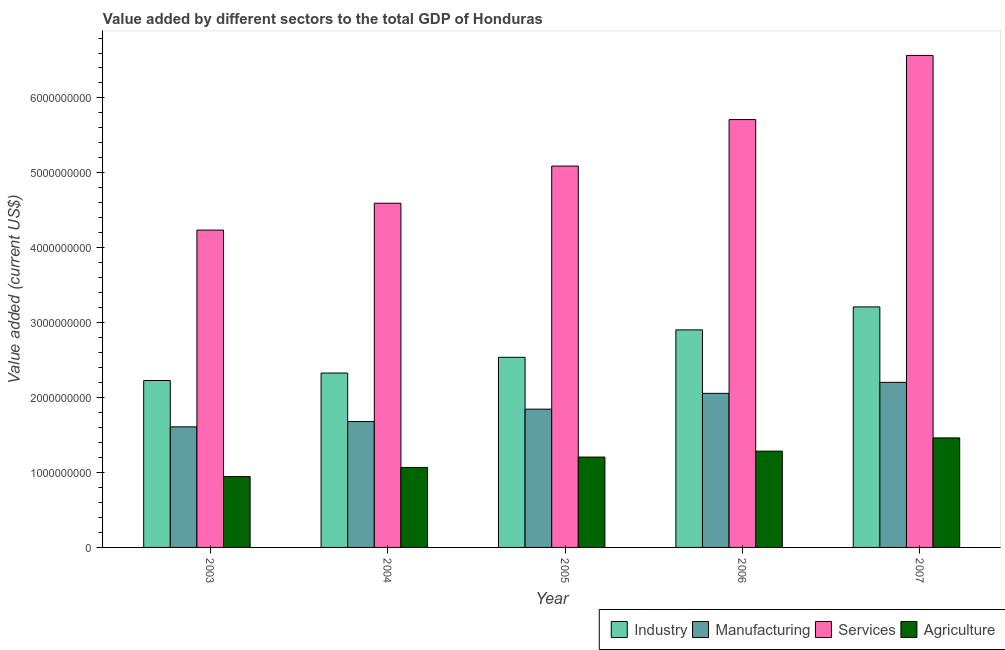How many different coloured bars are there?
Make the answer very short. 4. How many bars are there on the 5th tick from the left?
Provide a short and direct response. 4. What is the value added by agricultural sector in 2007?
Your answer should be very brief. 1.46e+09. Across all years, what is the maximum value added by manufacturing sector?
Provide a succinct answer. 2.20e+09. Across all years, what is the minimum value added by industrial sector?
Offer a terse response. 2.23e+09. In which year was the value added by industrial sector minimum?
Your response must be concise. 2003. What is the total value added by industrial sector in the graph?
Ensure brevity in your answer.  1.32e+1. What is the difference between the value added by manufacturing sector in 2005 and that in 2006?
Provide a succinct answer. -2.11e+08. What is the difference between the value added by manufacturing sector in 2007 and the value added by industrial sector in 2006?
Ensure brevity in your answer.  1.47e+08. What is the average value added by agricultural sector per year?
Make the answer very short. 1.19e+09. In how many years, is the value added by services sector greater than 4200000000 US$?
Your answer should be very brief. 5. What is the ratio of the value added by manufacturing sector in 2005 to that in 2006?
Ensure brevity in your answer.  0.9. What is the difference between the highest and the second highest value added by manufacturing sector?
Provide a succinct answer. 1.47e+08. What is the difference between the highest and the lowest value added by agricultural sector?
Ensure brevity in your answer.  5.17e+08. Is the sum of the value added by agricultural sector in 2005 and 2006 greater than the maximum value added by industrial sector across all years?
Give a very brief answer. Yes. Is it the case that in every year, the sum of the value added by services sector and value added by agricultural sector is greater than the sum of value added by manufacturing sector and value added by industrial sector?
Your answer should be very brief. Yes. What does the 2nd bar from the left in 2007 represents?
Offer a terse response. Manufacturing. What does the 3rd bar from the right in 2005 represents?
Make the answer very short. Manufacturing. Is it the case that in every year, the sum of the value added by industrial sector and value added by manufacturing sector is greater than the value added by services sector?
Ensure brevity in your answer.  No. How many bars are there?
Your answer should be compact. 20. Are all the bars in the graph horizontal?
Give a very brief answer. No. How many years are there in the graph?
Ensure brevity in your answer.  5. Does the graph contain any zero values?
Your response must be concise. No. How many legend labels are there?
Your response must be concise. 4. How are the legend labels stacked?
Ensure brevity in your answer.  Horizontal. What is the title of the graph?
Give a very brief answer. Value added by different sectors to the total GDP of Honduras. Does "Luxembourg" appear as one of the legend labels in the graph?
Your response must be concise. No. What is the label or title of the Y-axis?
Your answer should be very brief. Value added (current US$). What is the Value added (current US$) of Industry in 2003?
Your answer should be compact. 2.23e+09. What is the Value added (current US$) of Manufacturing in 2003?
Provide a short and direct response. 1.61e+09. What is the Value added (current US$) in Services in 2003?
Your answer should be very brief. 4.24e+09. What is the Value added (current US$) in Agriculture in 2003?
Keep it short and to the point. 9.45e+08. What is the Value added (current US$) in Industry in 2004?
Offer a terse response. 2.33e+09. What is the Value added (current US$) in Manufacturing in 2004?
Offer a very short reply. 1.68e+09. What is the Value added (current US$) of Services in 2004?
Ensure brevity in your answer.  4.59e+09. What is the Value added (current US$) of Agriculture in 2004?
Give a very brief answer. 1.07e+09. What is the Value added (current US$) of Industry in 2005?
Offer a very short reply. 2.54e+09. What is the Value added (current US$) of Manufacturing in 2005?
Your answer should be compact. 1.85e+09. What is the Value added (current US$) of Services in 2005?
Ensure brevity in your answer.  5.09e+09. What is the Value added (current US$) of Agriculture in 2005?
Offer a very short reply. 1.21e+09. What is the Value added (current US$) of Industry in 2006?
Ensure brevity in your answer.  2.90e+09. What is the Value added (current US$) of Manufacturing in 2006?
Offer a terse response. 2.06e+09. What is the Value added (current US$) in Services in 2006?
Your response must be concise. 5.71e+09. What is the Value added (current US$) in Agriculture in 2006?
Provide a short and direct response. 1.29e+09. What is the Value added (current US$) of Industry in 2007?
Give a very brief answer. 3.21e+09. What is the Value added (current US$) in Manufacturing in 2007?
Offer a terse response. 2.20e+09. What is the Value added (current US$) of Services in 2007?
Give a very brief answer. 6.57e+09. What is the Value added (current US$) of Agriculture in 2007?
Your answer should be very brief. 1.46e+09. Across all years, what is the maximum Value added (current US$) of Industry?
Your answer should be compact. 3.21e+09. Across all years, what is the maximum Value added (current US$) of Manufacturing?
Provide a short and direct response. 2.20e+09. Across all years, what is the maximum Value added (current US$) in Services?
Offer a very short reply. 6.57e+09. Across all years, what is the maximum Value added (current US$) in Agriculture?
Give a very brief answer. 1.46e+09. Across all years, what is the minimum Value added (current US$) in Industry?
Provide a succinct answer. 2.23e+09. Across all years, what is the minimum Value added (current US$) of Manufacturing?
Ensure brevity in your answer.  1.61e+09. Across all years, what is the minimum Value added (current US$) in Services?
Make the answer very short. 4.24e+09. Across all years, what is the minimum Value added (current US$) in Agriculture?
Ensure brevity in your answer.  9.45e+08. What is the total Value added (current US$) of Industry in the graph?
Your response must be concise. 1.32e+1. What is the total Value added (current US$) of Manufacturing in the graph?
Your answer should be compact. 9.40e+09. What is the total Value added (current US$) in Services in the graph?
Keep it short and to the point. 2.62e+1. What is the total Value added (current US$) of Agriculture in the graph?
Your answer should be compact. 5.97e+09. What is the difference between the Value added (current US$) of Industry in 2003 and that in 2004?
Your answer should be compact. -9.98e+07. What is the difference between the Value added (current US$) in Manufacturing in 2003 and that in 2004?
Ensure brevity in your answer.  -7.09e+07. What is the difference between the Value added (current US$) in Services in 2003 and that in 2004?
Provide a short and direct response. -3.59e+08. What is the difference between the Value added (current US$) in Agriculture in 2003 and that in 2004?
Provide a succinct answer. -1.22e+08. What is the difference between the Value added (current US$) in Industry in 2003 and that in 2005?
Offer a terse response. -3.10e+08. What is the difference between the Value added (current US$) in Manufacturing in 2003 and that in 2005?
Make the answer very short. -2.36e+08. What is the difference between the Value added (current US$) in Services in 2003 and that in 2005?
Keep it short and to the point. -8.55e+08. What is the difference between the Value added (current US$) of Agriculture in 2003 and that in 2005?
Make the answer very short. -2.61e+08. What is the difference between the Value added (current US$) of Industry in 2003 and that in 2006?
Provide a succinct answer. -6.76e+08. What is the difference between the Value added (current US$) in Manufacturing in 2003 and that in 2006?
Give a very brief answer. -4.47e+08. What is the difference between the Value added (current US$) in Services in 2003 and that in 2006?
Keep it short and to the point. -1.48e+09. What is the difference between the Value added (current US$) of Agriculture in 2003 and that in 2006?
Keep it short and to the point. -3.40e+08. What is the difference between the Value added (current US$) in Industry in 2003 and that in 2007?
Your answer should be compact. -9.83e+08. What is the difference between the Value added (current US$) in Manufacturing in 2003 and that in 2007?
Keep it short and to the point. -5.94e+08. What is the difference between the Value added (current US$) in Services in 2003 and that in 2007?
Your answer should be very brief. -2.33e+09. What is the difference between the Value added (current US$) in Agriculture in 2003 and that in 2007?
Offer a terse response. -5.17e+08. What is the difference between the Value added (current US$) in Industry in 2004 and that in 2005?
Provide a short and direct response. -2.10e+08. What is the difference between the Value added (current US$) of Manufacturing in 2004 and that in 2005?
Keep it short and to the point. -1.65e+08. What is the difference between the Value added (current US$) in Services in 2004 and that in 2005?
Ensure brevity in your answer.  -4.96e+08. What is the difference between the Value added (current US$) in Agriculture in 2004 and that in 2005?
Ensure brevity in your answer.  -1.39e+08. What is the difference between the Value added (current US$) in Industry in 2004 and that in 2006?
Make the answer very short. -5.76e+08. What is the difference between the Value added (current US$) in Manufacturing in 2004 and that in 2006?
Give a very brief answer. -3.76e+08. What is the difference between the Value added (current US$) of Services in 2004 and that in 2006?
Your response must be concise. -1.12e+09. What is the difference between the Value added (current US$) of Agriculture in 2004 and that in 2006?
Offer a terse response. -2.18e+08. What is the difference between the Value added (current US$) in Industry in 2004 and that in 2007?
Offer a terse response. -8.83e+08. What is the difference between the Value added (current US$) in Manufacturing in 2004 and that in 2007?
Your answer should be very brief. -5.23e+08. What is the difference between the Value added (current US$) in Services in 2004 and that in 2007?
Your answer should be compact. -1.97e+09. What is the difference between the Value added (current US$) in Agriculture in 2004 and that in 2007?
Offer a terse response. -3.95e+08. What is the difference between the Value added (current US$) in Industry in 2005 and that in 2006?
Make the answer very short. -3.66e+08. What is the difference between the Value added (current US$) of Manufacturing in 2005 and that in 2006?
Your answer should be compact. -2.11e+08. What is the difference between the Value added (current US$) of Services in 2005 and that in 2006?
Your answer should be compact. -6.21e+08. What is the difference between the Value added (current US$) of Agriculture in 2005 and that in 2006?
Offer a very short reply. -7.93e+07. What is the difference between the Value added (current US$) of Industry in 2005 and that in 2007?
Provide a succinct answer. -6.73e+08. What is the difference between the Value added (current US$) of Manufacturing in 2005 and that in 2007?
Your answer should be very brief. -3.58e+08. What is the difference between the Value added (current US$) of Services in 2005 and that in 2007?
Make the answer very short. -1.48e+09. What is the difference between the Value added (current US$) of Agriculture in 2005 and that in 2007?
Make the answer very short. -2.56e+08. What is the difference between the Value added (current US$) of Industry in 2006 and that in 2007?
Offer a terse response. -3.07e+08. What is the difference between the Value added (current US$) in Manufacturing in 2006 and that in 2007?
Give a very brief answer. -1.47e+08. What is the difference between the Value added (current US$) of Services in 2006 and that in 2007?
Provide a short and direct response. -8.56e+08. What is the difference between the Value added (current US$) of Agriculture in 2006 and that in 2007?
Make the answer very short. -1.77e+08. What is the difference between the Value added (current US$) of Industry in 2003 and the Value added (current US$) of Manufacturing in 2004?
Offer a terse response. 5.48e+08. What is the difference between the Value added (current US$) of Industry in 2003 and the Value added (current US$) of Services in 2004?
Make the answer very short. -2.37e+09. What is the difference between the Value added (current US$) of Industry in 2003 and the Value added (current US$) of Agriculture in 2004?
Make the answer very short. 1.16e+09. What is the difference between the Value added (current US$) of Manufacturing in 2003 and the Value added (current US$) of Services in 2004?
Offer a very short reply. -2.98e+09. What is the difference between the Value added (current US$) of Manufacturing in 2003 and the Value added (current US$) of Agriculture in 2004?
Offer a very short reply. 5.42e+08. What is the difference between the Value added (current US$) in Services in 2003 and the Value added (current US$) in Agriculture in 2004?
Your answer should be compact. 3.17e+09. What is the difference between the Value added (current US$) in Industry in 2003 and the Value added (current US$) in Manufacturing in 2005?
Make the answer very short. 3.82e+08. What is the difference between the Value added (current US$) of Industry in 2003 and the Value added (current US$) of Services in 2005?
Ensure brevity in your answer.  -2.86e+09. What is the difference between the Value added (current US$) of Industry in 2003 and the Value added (current US$) of Agriculture in 2005?
Provide a short and direct response. 1.02e+09. What is the difference between the Value added (current US$) of Manufacturing in 2003 and the Value added (current US$) of Services in 2005?
Make the answer very short. -3.48e+09. What is the difference between the Value added (current US$) of Manufacturing in 2003 and the Value added (current US$) of Agriculture in 2005?
Offer a very short reply. 4.03e+08. What is the difference between the Value added (current US$) of Services in 2003 and the Value added (current US$) of Agriculture in 2005?
Provide a short and direct response. 3.03e+09. What is the difference between the Value added (current US$) in Industry in 2003 and the Value added (current US$) in Manufacturing in 2006?
Provide a succinct answer. 1.71e+08. What is the difference between the Value added (current US$) of Industry in 2003 and the Value added (current US$) of Services in 2006?
Your response must be concise. -3.48e+09. What is the difference between the Value added (current US$) of Industry in 2003 and the Value added (current US$) of Agriculture in 2006?
Ensure brevity in your answer.  9.43e+08. What is the difference between the Value added (current US$) in Manufacturing in 2003 and the Value added (current US$) in Services in 2006?
Provide a short and direct response. -4.10e+09. What is the difference between the Value added (current US$) in Manufacturing in 2003 and the Value added (current US$) in Agriculture in 2006?
Offer a terse response. 3.24e+08. What is the difference between the Value added (current US$) of Services in 2003 and the Value added (current US$) of Agriculture in 2006?
Offer a terse response. 2.95e+09. What is the difference between the Value added (current US$) in Industry in 2003 and the Value added (current US$) in Manufacturing in 2007?
Make the answer very short. 2.45e+07. What is the difference between the Value added (current US$) of Industry in 2003 and the Value added (current US$) of Services in 2007?
Give a very brief answer. -4.34e+09. What is the difference between the Value added (current US$) in Industry in 2003 and the Value added (current US$) in Agriculture in 2007?
Give a very brief answer. 7.66e+08. What is the difference between the Value added (current US$) of Manufacturing in 2003 and the Value added (current US$) of Services in 2007?
Provide a succinct answer. -4.96e+09. What is the difference between the Value added (current US$) of Manufacturing in 2003 and the Value added (current US$) of Agriculture in 2007?
Your answer should be compact. 1.48e+08. What is the difference between the Value added (current US$) of Services in 2003 and the Value added (current US$) of Agriculture in 2007?
Give a very brief answer. 2.77e+09. What is the difference between the Value added (current US$) of Industry in 2004 and the Value added (current US$) of Manufacturing in 2005?
Your response must be concise. 4.82e+08. What is the difference between the Value added (current US$) in Industry in 2004 and the Value added (current US$) in Services in 2005?
Provide a short and direct response. -2.76e+09. What is the difference between the Value added (current US$) of Industry in 2004 and the Value added (current US$) of Agriculture in 2005?
Provide a short and direct response. 1.12e+09. What is the difference between the Value added (current US$) in Manufacturing in 2004 and the Value added (current US$) in Services in 2005?
Make the answer very short. -3.41e+09. What is the difference between the Value added (current US$) in Manufacturing in 2004 and the Value added (current US$) in Agriculture in 2005?
Offer a very short reply. 4.74e+08. What is the difference between the Value added (current US$) of Services in 2004 and the Value added (current US$) of Agriculture in 2005?
Keep it short and to the point. 3.39e+09. What is the difference between the Value added (current US$) of Industry in 2004 and the Value added (current US$) of Manufacturing in 2006?
Offer a terse response. 2.71e+08. What is the difference between the Value added (current US$) of Industry in 2004 and the Value added (current US$) of Services in 2006?
Provide a short and direct response. -3.38e+09. What is the difference between the Value added (current US$) of Industry in 2004 and the Value added (current US$) of Agriculture in 2006?
Keep it short and to the point. 1.04e+09. What is the difference between the Value added (current US$) in Manufacturing in 2004 and the Value added (current US$) in Services in 2006?
Provide a succinct answer. -4.03e+09. What is the difference between the Value added (current US$) of Manufacturing in 2004 and the Value added (current US$) of Agriculture in 2006?
Your answer should be very brief. 3.95e+08. What is the difference between the Value added (current US$) of Services in 2004 and the Value added (current US$) of Agriculture in 2006?
Provide a short and direct response. 3.31e+09. What is the difference between the Value added (current US$) in Industry in 2004 and the Value added (current US$) in Manufacturing in 2007?
Offer a terse response. 1.24e+08. What is the difference between the Value added (current US$) of Industry in 2004 and the Value added (current US$) of Services in 2007?
Offer a terse response. -4.24e+09. What is the difference between the Value added (current US$) in Industry in 2004 and the Value added (current US$) in Agriculture in 2007?
Offer a terse response. 8.66e+08. What is the difference between the Value added (current US$) of Manufacturing in 2004 and the Value added (current US$) of Services in 2007?
Your answer should be very brief. -4.89e+09. What is the difference between the Value added (current US$) of Manufacturing in 2004 and the Value added (current US$) of Agriculture in 2007?
Make the answer very short. 2.18e+08. What is the difference between the Value added (current US$) of Services in 2004 and the Value added (current US$) of Agriculture in 2007?
Your answer should be compact. 3.13e+09. What is the difference between the Value added (current US$) in Industry in 2005 and the Value added (current US$) in Manufacturing in 2006?
Offer a very short reply. 4.81e+08. What is the difference between the Value added (current US$) of Industry in 2005 and the Value added (current US$) of Services in 2006?
Provide a short and direct response. -3.17e+09. What is the difference between the Value added (current US$) of Industry in 2005 and the Value added (current US$) of Agriculture in 2006?
Provide a short and direct response. 1.25e+09. What is the difference between the Value added (current US$) of Manufacturing in 2005 and the Value added (current US$) of Services in 2006?
Provide a short and direct response. -3.87e+09. What is the difference between the Value added (current US$) of Manufacturing in 2005 and the Value added (current US$) of Agriculture in 2006?
Offer a very short reply. 5.60e+08. What is the difference between the Value added (current US$) in Services in 2005 and the Value added (current US$) in Agriculture in 2006?
Provide a succinct answer. 3.81e+09. What is the difference between the Value added (current US$) in Industry in 2005 and the Value added (current US$) in Manufacturing in 2007?
Your answer should be compact. 3.34e+08. What is the difference between the Value added (current US$) in Industry in 2005 and the Value added (current US$) in Services in 2007?
Offer a very short reply. -4.03e+09. What is the difference between the Value added (current US$) of Industry in 2005 and the Value added (current US$) of Agriculture in 2007?
Give a very brief answer. 1.08e+09. What is the difference between the Value added (current US$) of Manufacturing in 2005 and the Value added (current US$) of Services in 2007?
Offer a terse response. -4.72e+09. What is the difference between the Value added (current US$) in Manufacturing in 2005 and the Value added (current US$) in Agriculture in 2007?
Make the answer very short. 3.84e+08. What is the difference between the Value added (current US$) in Services in 2005 and the Value added (current US$) in Agriculture in 2007?
Keep it short and to the point. 3.63e+09. What is the difference between the Value added (current US$) of Industry in 2006 and the Value added (current US$) of Manufacturing in 2007?
Give a very brief answer. 7.00e+08. What is the difference between the Value added (current US$) in Industry in 2006 and the Value added (current US$) in Services in 2007?
Offer a very short reply. -3.66e+09. What is the difference between the Value added (current US$) in Industry in 2006 and the Value added (current US$) in Agriculture in 2007?
Offer a very short reply. 1.44e+09. What is the difference between the Value added (current US$) in Manufacturing in 2006 and the Value added (current US$) in Services in 2007?
Your answer should be compact. -4.51e+09. What is the difference between the Value added (current US$) of Manufacturing in 2006 and the Value added (current US$) of Agriculture in 2007?
Offer a terse response. 5.95e+08. What is the difference between the Value added (current US$) of Services in 2006 and the Value added (current US$) of Agriculture in 2007?
Your answer should be very brief. 4.25e+09. What is the average Value added (current US$) of Industry per year?
Provide a succinct answer. 2.64e+09. What is the average Value added (current US$) in Manufacturing per year?
Offer a terse response. 1.88e+09. What is the average Value added (current US$) in Services per year?
Make the answer very short. 5.24e+09. What is the average Value added (current US$) of Agriculture per year?
Provide a succinct answer. 1.19e+09. In the year 2003, what is the difference between the Value added (current US$) in Industry and Value added (current US$) in Manufacturing?
Make the answer very short. 6.18e+08. In the year 2003, what is the difference between the Value added (current US$) in Industry and Value added (current US$) in Services?
Ensure brevity in your answer.  -2.01e+09. In the year 2003, what is the difference between the Value added (current US$) in Industry and Value added (current US$) in Agriculture?
Keep it short and to the point. 1.28e+09. In the year 2003, what is the difference between the Value added (current US$) of Manufacturing and Value added (current US$) of Services?
Offer a very short reply. -2.63e+09. In the year 2003, what is the difference between the Value added (current US$) of Manufacturing and Value added (current US$) of Agriculture?
Offer a terse response. 6.64e+08. In the year 2003, what is the difference between the Value added (current US$) in Services and Value added (current US$) in Agriculture?
Offer a very short reply. 3.29e+09. In the year 2004, what is the difference between the Value added (current US$) in Industry and Value added (current US$) in Manufacturing?
Offer a terse response. 6.47e+08. In the year 2004, what is the difference between the Value added (current US$) of Industry and Value added (current US$) of Services?
Your answer should be compact. -2.27e+09. In the year 2004, what is the difference between the Value added (current US$) of Industry and Value added (current US$) of Agriculture?
Give a very brief answer. 1.26e+09. In the year 2004, what is the difference between the Value added (current US$) in Manufacturing and Value added (current US$) in Services?
Keep it short and to the point. -2.91e+09. In the year 2004, what is the difference between the Value added (current US$) of Manufacturing and Value added (current US$) of Agriculture?
Your answer should be compact. 6.13e+08. In the year 2004, what is the difference between the Value added (current US$) of Services and Value added (current US$) of Agriculture?
Give a very brief answer. 3.53e+09. In the year 2005, what is the difference between the Value added (current US$) of Industry and Value added (current US$) of Manufacturing?
Ensure brevity in your answer.  6.92e+08. In the year 2005, what is the difference between the Value added (current US$) in Industry and Value added (current US$) in Services?
Give a very brief answer. -2.55e+09. In the year 2005, what is the difference between the Value added (current US$) in Industry and Value added (current US$) in Agriculture?
Offer a very short reply. 1.33e+09. In the year 2005, what is the difference between the Value added (current US$) of Manufacturing and Value added (current US$) of Services?
Ensure brevity in your answer.  -3.25e+09. In the year 2005, what is the difference between the Value added (current US$) in Manufacturing and Value added (current US$) in Agriculture?
Make the answer very short. 6.40e+08. In the year 2005, what is the difference between the Value added (current US$) in Services and Value added (current US$) in Agriculture?
Keep it short and to the point. 3.88e+09. In the year 2006, what is the difference between the Value added (current US$) of Industry and Value added (current US$) of Manufacturing?
Make the answer very short. 8.47e+08. In the year 2006, what is the difference between the Value added (current US$) of Industry and Value added (current US$) of Services?
Give a very brief answer. -2.81e+09. In the year 2006, what is the difference between the Value added (current US$) in Industry and Value added (current US$) in Agriculture?
Ensure brevity in your answer.  1.62e+09. In the year 2006, what is the difference between the Value added (current US$) in Manufacturing and Value added (current US$) in Services?
Offer a very short reply. -3.65e+09. In the year 2006, what is the difference between the Value added (current US$) in Manufacturing and Value added (current US$) in Agriculture?
Your answer should be very brief. 7.71e+08. In the year 2006, what is the difference between the Value added (current US$) of Services and Value added (current US$) of Agriculture?
Offer a terse response. 4.43e+09. In the year 2007, what is the difference between the Value added (current US$) in Industry and Value added (current US$) in Manufacturing?
Make the answer very short. 1.01e+09. In the year 2007, what is the difference between the Value added (current US$) of Industry and Value added (current US$) of Services?
Provide a succinct answer. -3.36e+09. In the year 2007, what is the difference between the Value added (current US$) of Industry and Value added (current US$) of Agriculture?
Your answer should be compact. 1.75e+09. In the year 2007, what is the difference between the Value added (current US$) in Manufacturing and Value added (current US$) in Services?
Your answer should be very brief. -4.36e+09. In the year 2007, what is the difference between the Value added (current US$) in Manufacturing and Value added (current US$) in Agriculture?
Offer a terse response. 7.41e+08. In the year 2007, what is the difference between the Value added (current US$) of Services and Value added (current US$) of Agriculture?
Offer a very short reply. 5.11e+09. What is the ratio of the Value added (current US$) of Industry in 2003 to that in 2004?
Your answer should be compact. 0.96. What is the ratio of the Value added (current US$) of Manufacturing in 2003 to that in 2004?
Provide a succinct answer. 0.96. What is the ratio of the Value added (current US$) in Services in 2003 to that in 2004?
Ensure brevity in your answer.  0.92. What is the ratio of the Value added (current US$) of Agriculture in 2003 to that in 2004?
Your answer should be very brief. 0.89. What is the ratio of the Value added (current US$) in Industry in 2003 to that in 2005?
Your answer should be very brief. 0.88. What is the ratio of the Value added (current US$) of Manufacturing in 2003 to that in 2005?
Provide a short and direct response. 0.87. What is the ratio of the Value added (current US$) of Services in 2003 to that in 2005?
Your answer should be very brief. 0.83. What is the ratio of the Value added (current US$) of Agriculture in 2003 to that in 2005?
Your answer should be compact. 0.78. What is the ratio of the Value added (current US$) of Industry in 2003 to that in 2006?
Make the answer very short. 0.77. What is the ratio of the Value added (current US$) in Manufacturing in 2003 to that in 2006?
Give a very brief answer. 0.78. What is the ratio of the Value added (current US$) of Services in 2003 to that in 2006?
Provide a short and direct response. 0.74. What is the ratio of the Value added (current US$) in Agriculture in 2003 to that in 2006?
Keep it short and to the point. 0.74. What is the ratio of the Value added (current US$) in Industry in 2003 to that in 2007?
Provide a short and direct response. 0.69. What is the ratio of the Value added (current US$) of Manufacturing in 2003 to that in 2007?
Keep it short and to the point. 0.73. What is the ratio of the Value added (current US$) in Services in 2003 to that in 2007?
Your answer should be compact. 0.65. What is the ratio of the Value added (current US$) in Agriculture in 2003 to that in 2007?
Ensure brevity in your answer.  0.65. What is the ratio of the Value added (current US$) of Industry in 2004 to that in 2005?
Keep it short and to the point. 0.92. What is the ratio of the Value added (current US$) in Manufacturing in 2004 to that in 2005?
Make the answer very short. 0.91. What is the ratio of the Value added (current US$) of Services in 2004 to that in 2005?
Your answer should be compact. 0.9. What is the ratio of the Value added (current US$) in Agriculture in 2004 to that in 2005?
Your response must be concise. 0.89. What is the ratio of the Value added (current US$) in Industry in 2004 to that in 2006?
Offer a very short reply. 0.8. What is the ratio of the Value added (current US$) in Manufacturing in 2004 to that in 2006?
Keep it short and to the point. 0.82. What is the ratio of the Value added (current US$) of Services in 2004 to that in 2006?
Give a very brief answer. 0.8. What is the ratio of the Value added (current US$) in Agriculture in 2004 to that in 2006?
Keep it short and to the point. 0.83. What is the ratio of the Value added (current US$) in Industry in 2004 to that in 2007?
Provide a short and direct response. 0.72. What is the ratio of the Value added (current US$) in Manufacturing in 2004 to that in 2007?
Your answer should be compact. 0.76. What is the ratio of the Value added (current US$) in Services in 2004 to that in 2007?
Give a very brief answer. 0.7. What is the ratio of the Value added (current US$) in Agriculture in 2004 to that in 2007?
Make the answer very short. 0.73. What is the ratio of the Value added (current US$) of Industry in 2005 to that in 2006?
Your response must be concise. 0.87. What is the ratio of the Value added (current US$) in Manufacturing in 2005 to that in 2006?
Your response must be concise. 0.9. What is the ratio of the Value added (current US$) of Services in 2005 to that in 2006?
Ensure brevity in your answer.  0.89. What is the ratio of the Value added (current US$) in Agriculture in 2005 to that in 2006?
Give a very brief answer. 0.94. What is the ratio of the Value added (current US$) of Industry in 2005 to that in 2007?
Provide a short and direct response. 0.79. What is the ratio of the Value added (current US$) of Manufacturing in 2005 to that in 2007?
Your answer should be very brief. 0.84. What is the ratio of the Value added (current US$) in Services in 2005 to that in 2007?
Offer a very short reply. 0.78. What is the ratio of the Value added (current US$) in Agriculture in 2005 to that in 2007?
Your answer should be very brief. 0.82. What is the ratio of the Value added (current US$) in Industry in 2006 to that in 2007?
Offer a very short reply. 0.9. What is the ratio of the Value added (current US$) in Manufacturing in 2006 to that in 2007?
Your answer should be compact. 0.93. What is the ratio of the Value added (current US$) in Services in 2006 to that in 2007?
Your response must be concise. 0.87. What is the ratio of the Value added (current US$) of Agriculture in 2006 to that in 2007?
Offer a very short reply. 0.88. What is the difference between the highest and the second highest Value added (current US$) of Industry?
Provide a succinct answer. 3.07e+08. What is the difference between the highest and the second highest Value added (current US$) in Manufacturing?
Your answer should be compact. 1.47e+08. What is the difference between the highest and the second highest Value added (current US$) in Services?
Your response must be concise. 8.56e+08. What is the difference between the highest and the second highest Value added (current US$) of Agriculture?
Keep it short and to the point. 1.77e+08. What is the difference between the highest and the lowest Value added (current US$) of Industry?
Ensure brevity in your answer.  9.83e+08. What is the difference between the highest and the lowest Value added (current US$) in Manufacturing?
Offer a very short reply. 5.94e+08. What is the difference between the highest and the lowest Value added (current US$) of Services?
Keep it short and to the point. 2.33e+09. What is the difference between the highest and the lowest Value added (current US$) in Agriculture?
Offer a terse response. 5.17e+08. 